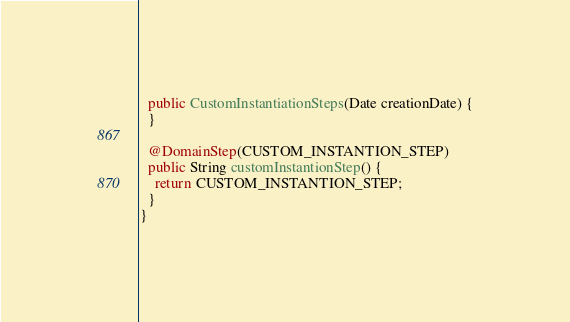<code> <loc_0><loc_0><loc_500><loc_500><_Java_>  public CustomInstantiationSteps(Date creationDate) {
  }
  
  @DomainStep(CUSTOM_INSTANTION_STEP)
  public String customInstantionStep() {
    return CUSTOM_INSTANTION_STEP;
  }
}
</code> 